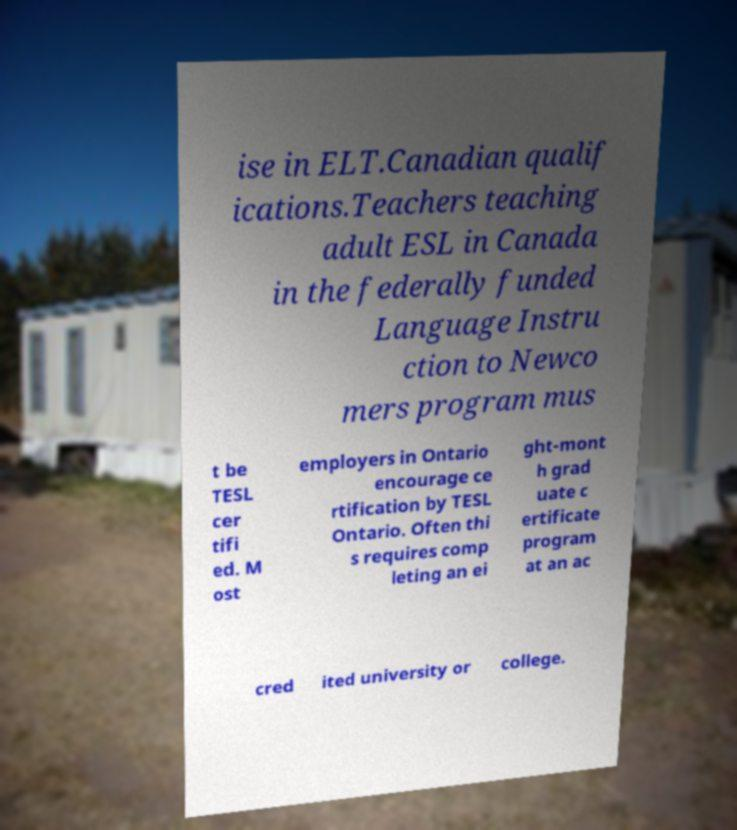Can you read and provide the text displayed in the image?This photo seems to have some interesting text. Can you extract and type it out for me? ise in ELT.Canadian qualif ications.Teachers teaching adult ESL in Canada in the federally funded Language Instru ction to Newco mers program mus t be TESL cer tifi ed. M ost employers in Ontario encourage ce rtification by TESL Ontario. Often thi s requires comp leting an ei ght-mont h grad uate c ertificate program at an ac cred ited university or college. 